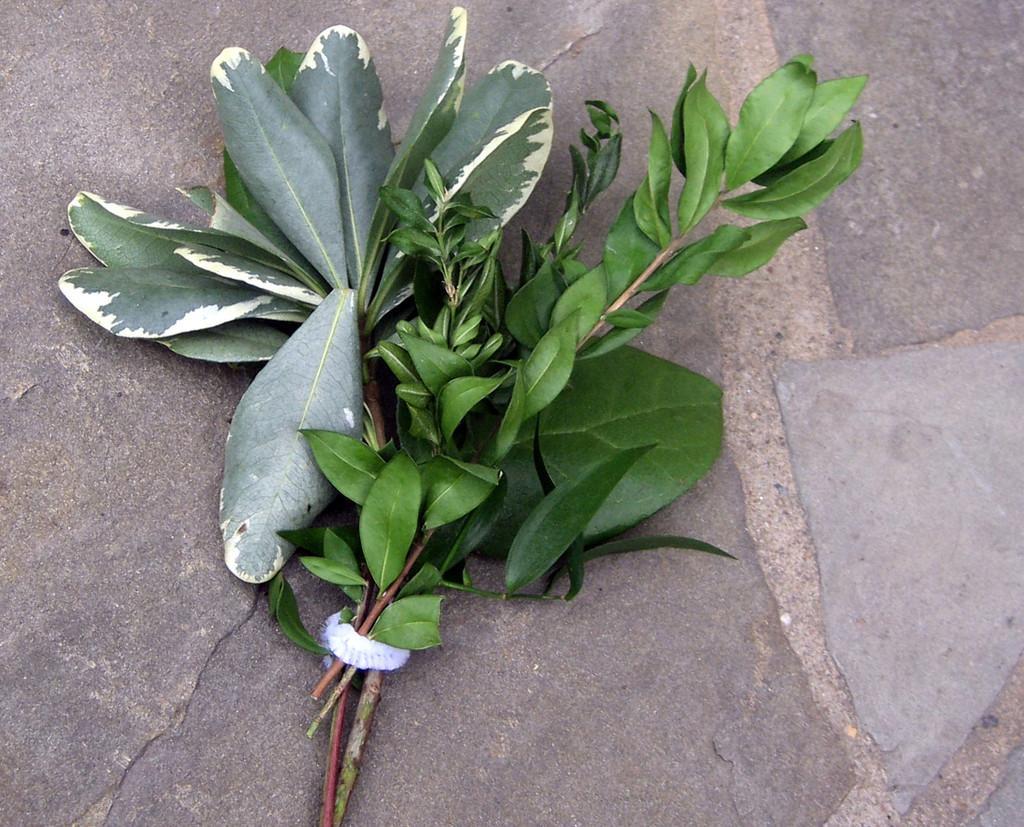Can you describe this image briefly? In this picture we can see there are two plants, which are tied with a white object and the plants are on the ground. 